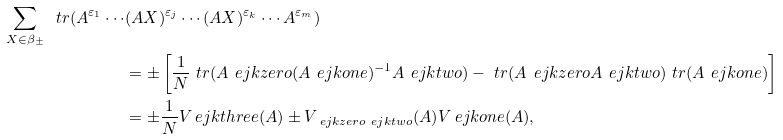<formula> <loc_0><loc_0><loc_500><loc_500>\sum _ { X \in \beta _ { \pm } } \ t r ( A ^ { \varepsilon _ { 1 } } \cdots & ( A X ) ^ { \varepsilon _ { j } } \cdots ( A X ) ^ { \varepsilon _ { k } } \cdots A ^ { \varepsilon _ { m } } ) \\ & = \pm \left [ \frac { 1 } { N } \ t r ( A ^ { \ } e j k z e r o ( A ^ { \ } e j k o n e ) ^ { - 1 } A ^ { \ } e j k t w o ) - \ t r ( A ^ { \ } e j k z e r o A ^ { \ } e j k t w o ) \ t r ( A ^ { \ } e j k o n e ) \right ] \\ & = \pm \frac { 1 } { N } V _ { \ } e j k t h r e e ( A ) \pm V _ { \ e j k z e r o \ e j k t w o } ( A ) V _ { \ } e j k o n e ( A ) ,</formula> 